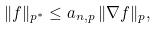<formula> <loc_0><loc_0><loc_500><loc_500>\| f \| _ { p ^ { * } } \leq a _ { n , p } \, \| \nabla f \| _ { p } ,</formula> 